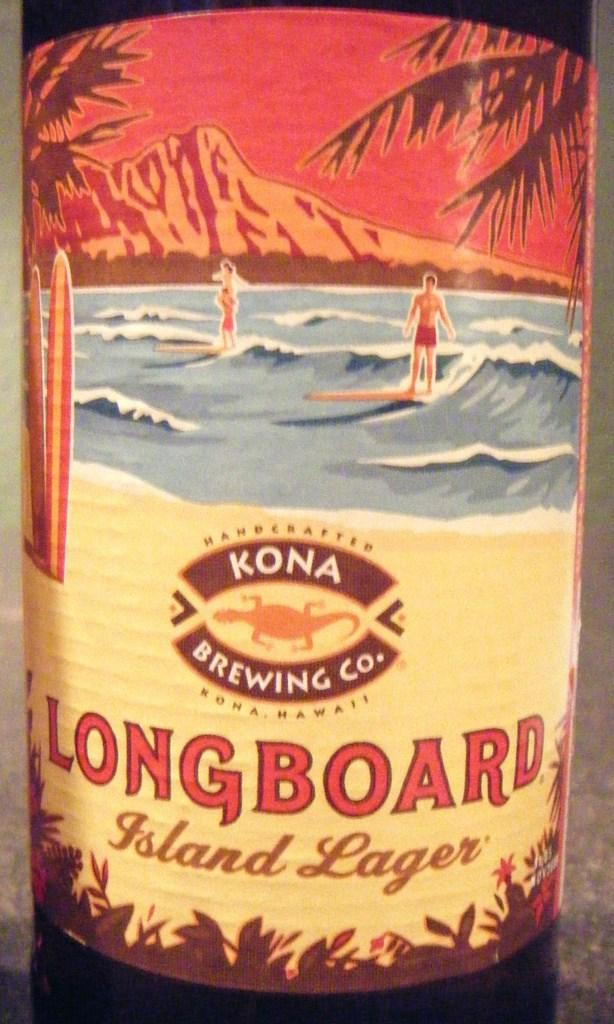<image>
Summarize the visual content of the image. Bottle of Longboard by Kona Brewing Company showing a man surfing on the label. 